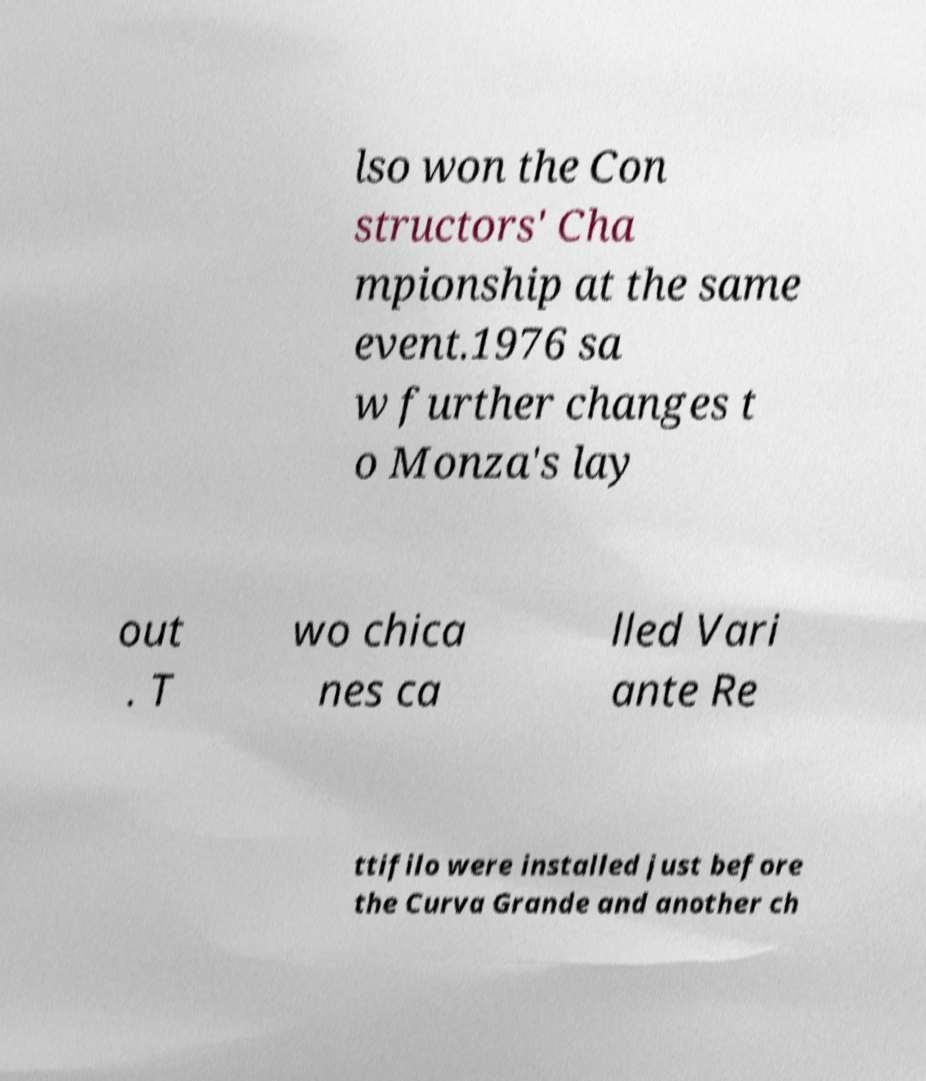For documentation purposes, I need the text within this image transcribed. Could you provide that? lso won the Con structors' Cha mpionship at the same event.1976 sa w further changes t o Monza's lay out . T wo chica nes ca lled Vari ante Re ttifilo were installed just before the Curva Grande and another ch 